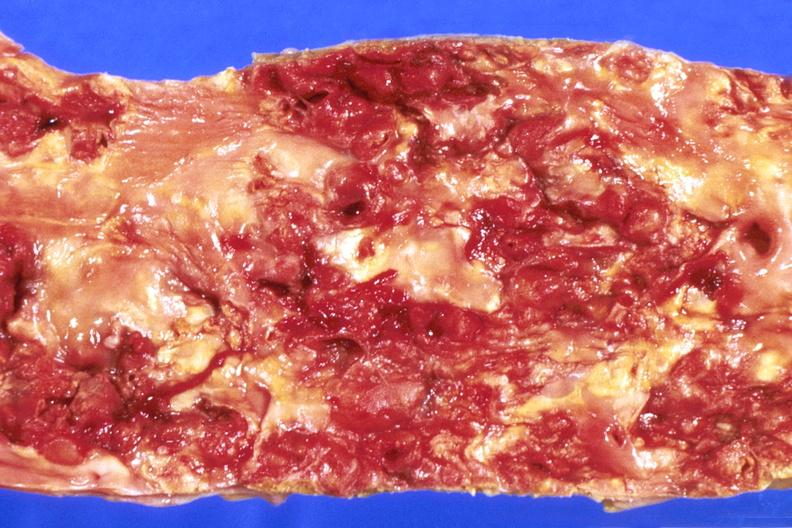s this present?
Answer the question using a single word or phrase. No 